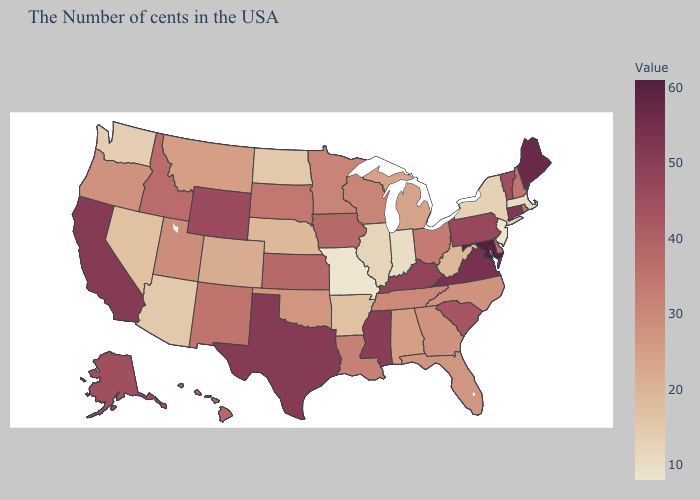Among the states that border Arkansas , which have the lowest value?
Short answer required. Missouri. Is the legend a continuous bar?
Answer briefly. Yes. Among the states that border Idaho , does Utah have the highest value?
Be succinct. No. Does the map have missing data?
Short answer required. No. Which states have the lowest value in the USA?
Be succinct. New Jersey, Missouri. 